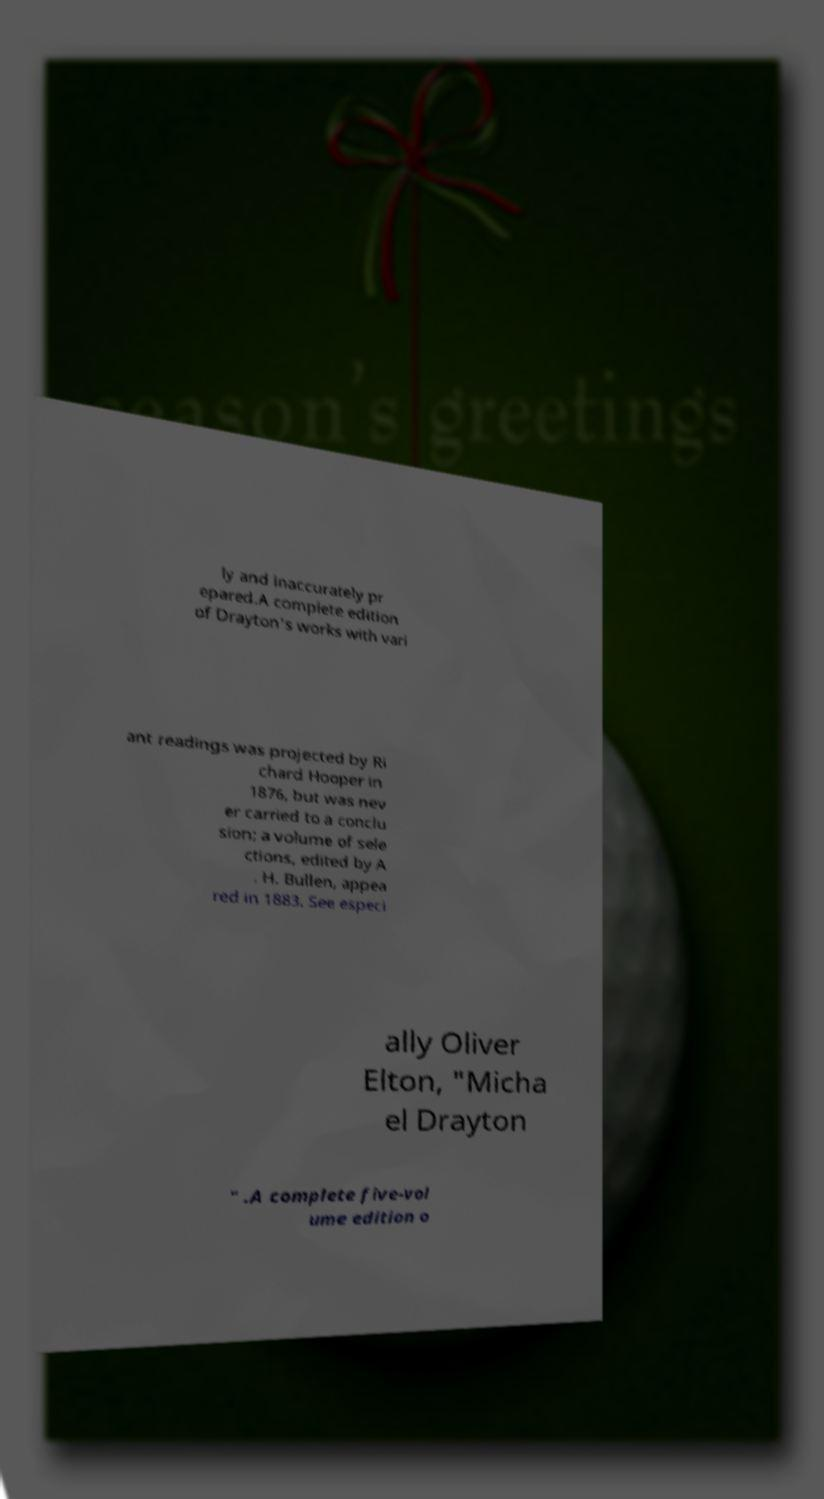Can you read and provide the text displayed in the image?This photo seems to have some interesting text. Can you extract and type it out for me? ly and inaccurately pr epared.A complete edition of Drayton's works with vari ant readings was projected by Ri chard Hooper in 1876, but was nev er carried to a conclu sion; a volume of sele ctions, edited by A . H. Bullen, appea red in 1883. See especi ally Oliver Elton, "Micha el Drayton " .A complete five-vol ume edition o 